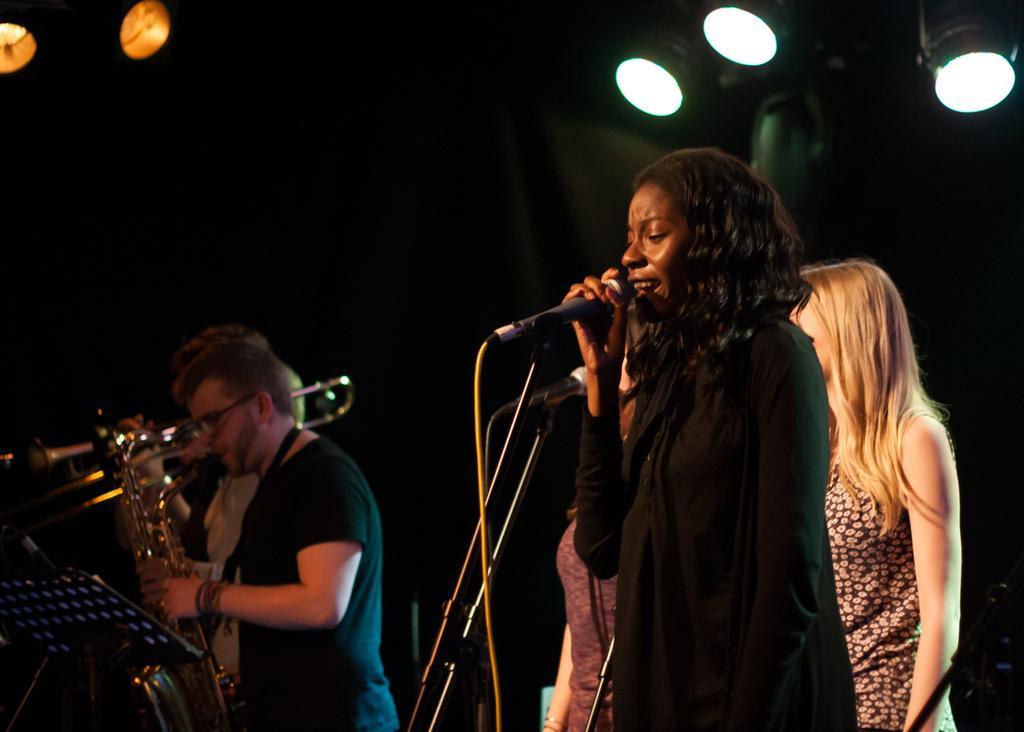Please provide a concise description of this image. Background portion of the picture is dark. At the top we can see lights. Here we can see people standing. These are mike's. Here we can see they are holding musical instruments. 